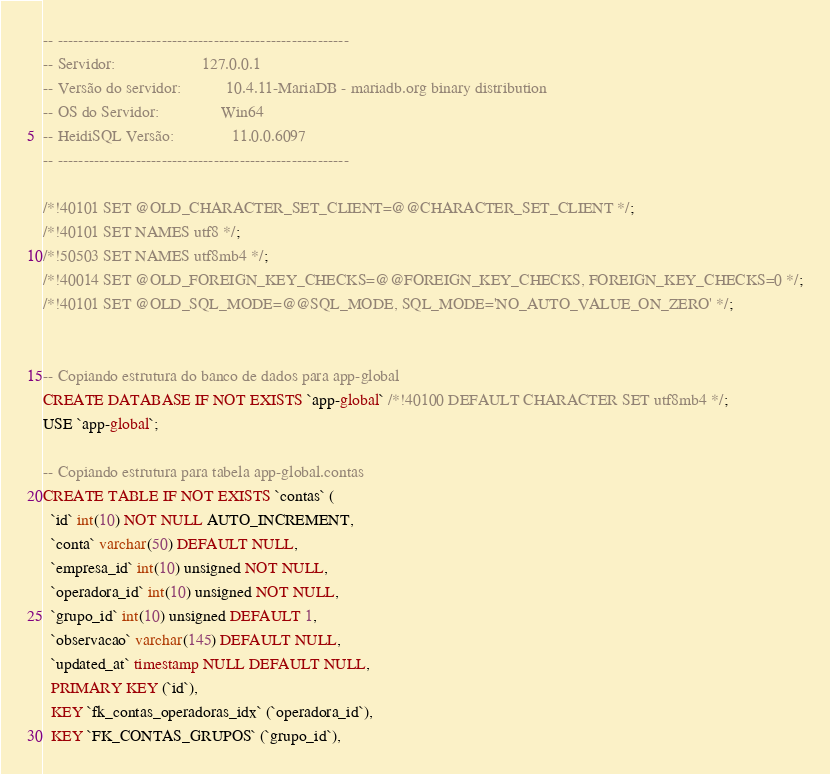Convert code to text. <code><loc_0><loc_0><loc_500><loc_500><_SQL_>-- --------------------------------------------------------
-- Servidor:                     127.0.0.1
-- Versão do servidor:           10.4.11-MariaDB - mariadb.org binary distribution
-- OS do Servidor:               Win64
-- HeidiSQL Versão:              11.0.0.6097
-- --------------------------------------------------------

/*!40101 SET @OLD_CHARACTER_SET_CLIENT=@@CHARACTER_SET_CLIENT */;
/*!40101 SET NAMES utf8 */;
/*!50503 SET NAMES utf8mb4 */;
/*!40014 SET @OLD_FOREIGN_KEY_CHECKS=@@FOREIGN_KEY_CHECKS, FOREIGN_KEY_CHECKS=0 */;
/*!40101 SET @OLD_SQL_MODE=@@SQL_MODE, SQL_MODE='NO_AUTO_VALUE_ON_ZERO' */;


-- Copiando estrutura do banco de dados para app-global
CREATE DATABASE IF NOT EXISTS `app-global` /*!40100 DEFAULT CHARACTER SET utf8mb4 */;
USE `app-global`;

-- Copiando estrutura para tabela app-global.contas
CREATE TABLE IF NOT EXISTS `contas` (
  `id` int(10) NOT NULL AUTO_INCREMENT,
  `conta` varchar(50) DEFAULT NULL,
  `empresa_id` int(10) unsigned NOT NULL,
  `operadora_id` int(10) unsigned NOT NULL,
  `grupo_id` int(10) unsigned DEFAULT 1,
  `observacao` varchar(145) DEFAULT NULL,
  `updated_at` timestamp NULL DEFAULT NULL,
  PRIMARY KEY (`id`),
  KEY `fk_contas_operadoras_idx` (`operadora_id`),
  KEY `FK_CONTAS_GRUPOS` (`grupo_id`),</code> 